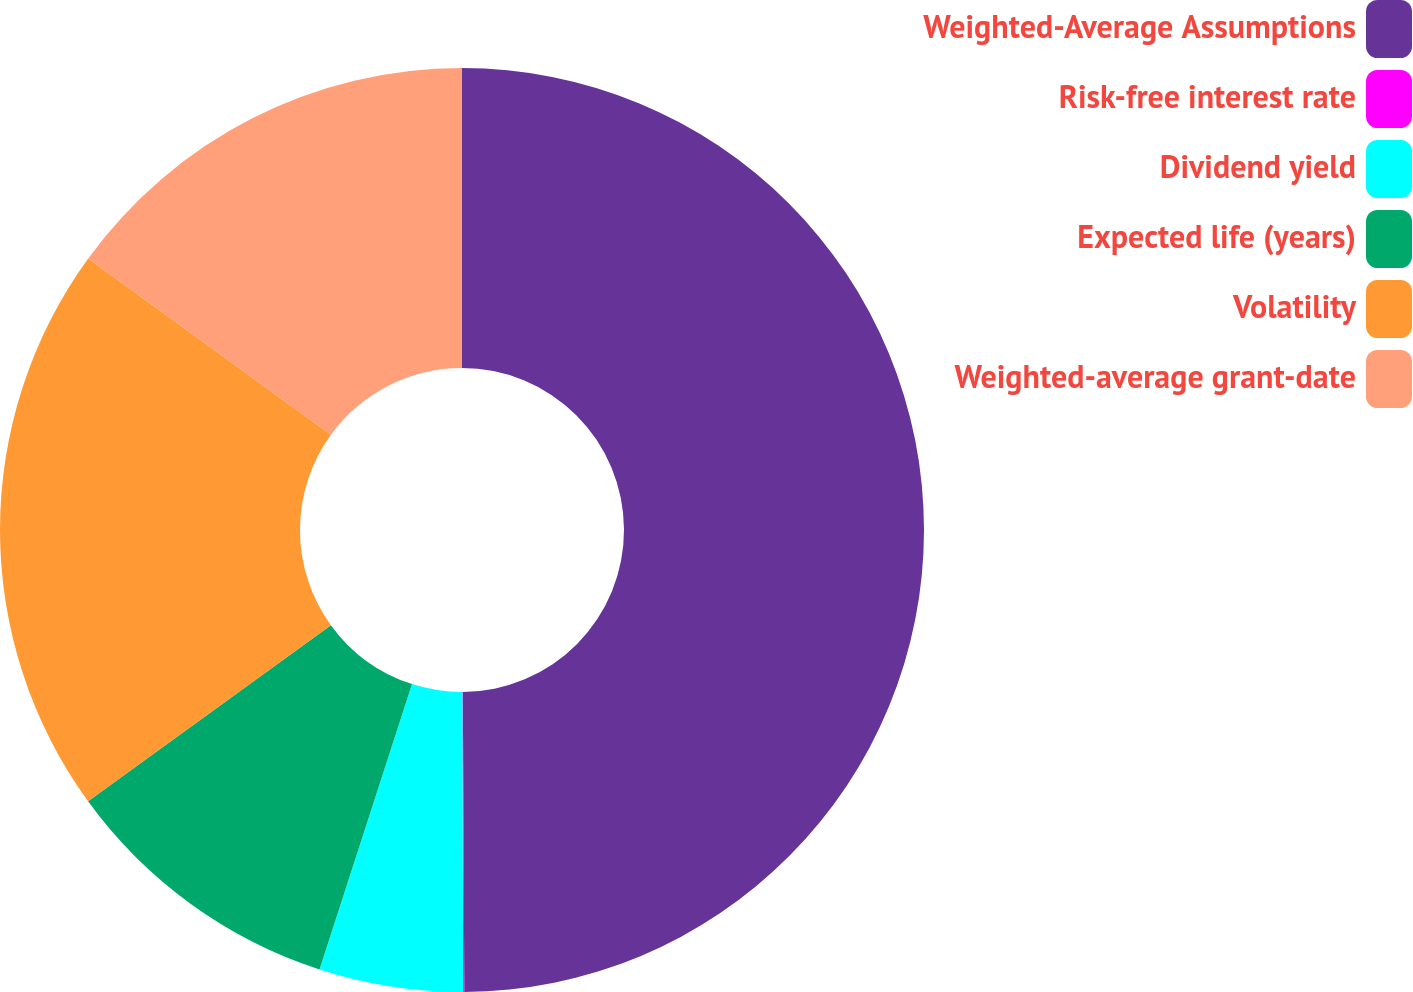Convert chart to OTSL. <chart><loc_0><loc_0><loc_500><loc_500><pie_chart><fcel>Weighted-Average Assumptions<fcel>Risk-free interest rate<fcel>Dividend yield<fcel>Expected life (years)<fcel>Volatility<fcel>Weighted-average grant-date<nl><fcel>49.92%<fcel>0.04%<fcel>5.03%<fcel>10.02%<fcel>19.99%<fcel>15.0%<nl></chart> 